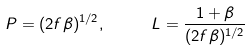Convert formula to latex. <formula><loc_0><loc_0><loc_500><loc_500>P = ( 2 f \beta ) ^ { 1 / 2 } , \ \quad L = \frac { 1 + \beta } { ( 2 f \beta ) ^ { 1 / 2 } }</formula> 